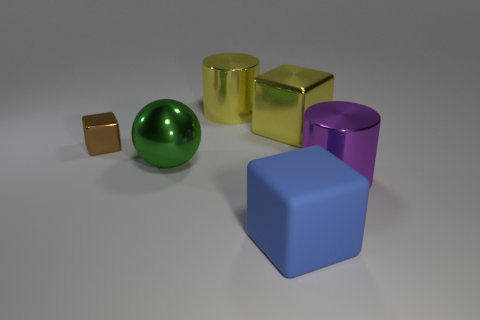Does the yellow cylinder have the same size as the shiny block right of the green metal sphere?
Your response must be concise. Yes. How big is the metal cylinder on the left side of the purple metal cylinder in front of the large yellow shiny cylinder?
Make the answer very short. Large. What number of cylinders have the same material as the large blue block?
Your response must be concise. 0. Are there any metal cylinders?
Give a very brief answer. Yes. There is a yellow shiny object that is left of the yellow metallic cube; how big is it?
Ensure brevity in your answer.  Large. What number of cylinders have the same color as the sphere?
Provide a short and direct response. 0. How many cylinders are either blue things or big brown metal objects?
Provide a succinct answer. 0. There is a big object that is right of the big rubber thing and behind the big green object; what is its shape?
Provide a succinct answer. Cube. Is there a brown thing that has the same size as the green shiny sphere?
Your answer should be very brief. No. How many objects are either big cylinders that are in front of the large green shiny sphere or big green cylinders?
Offer a terse response. 1. 